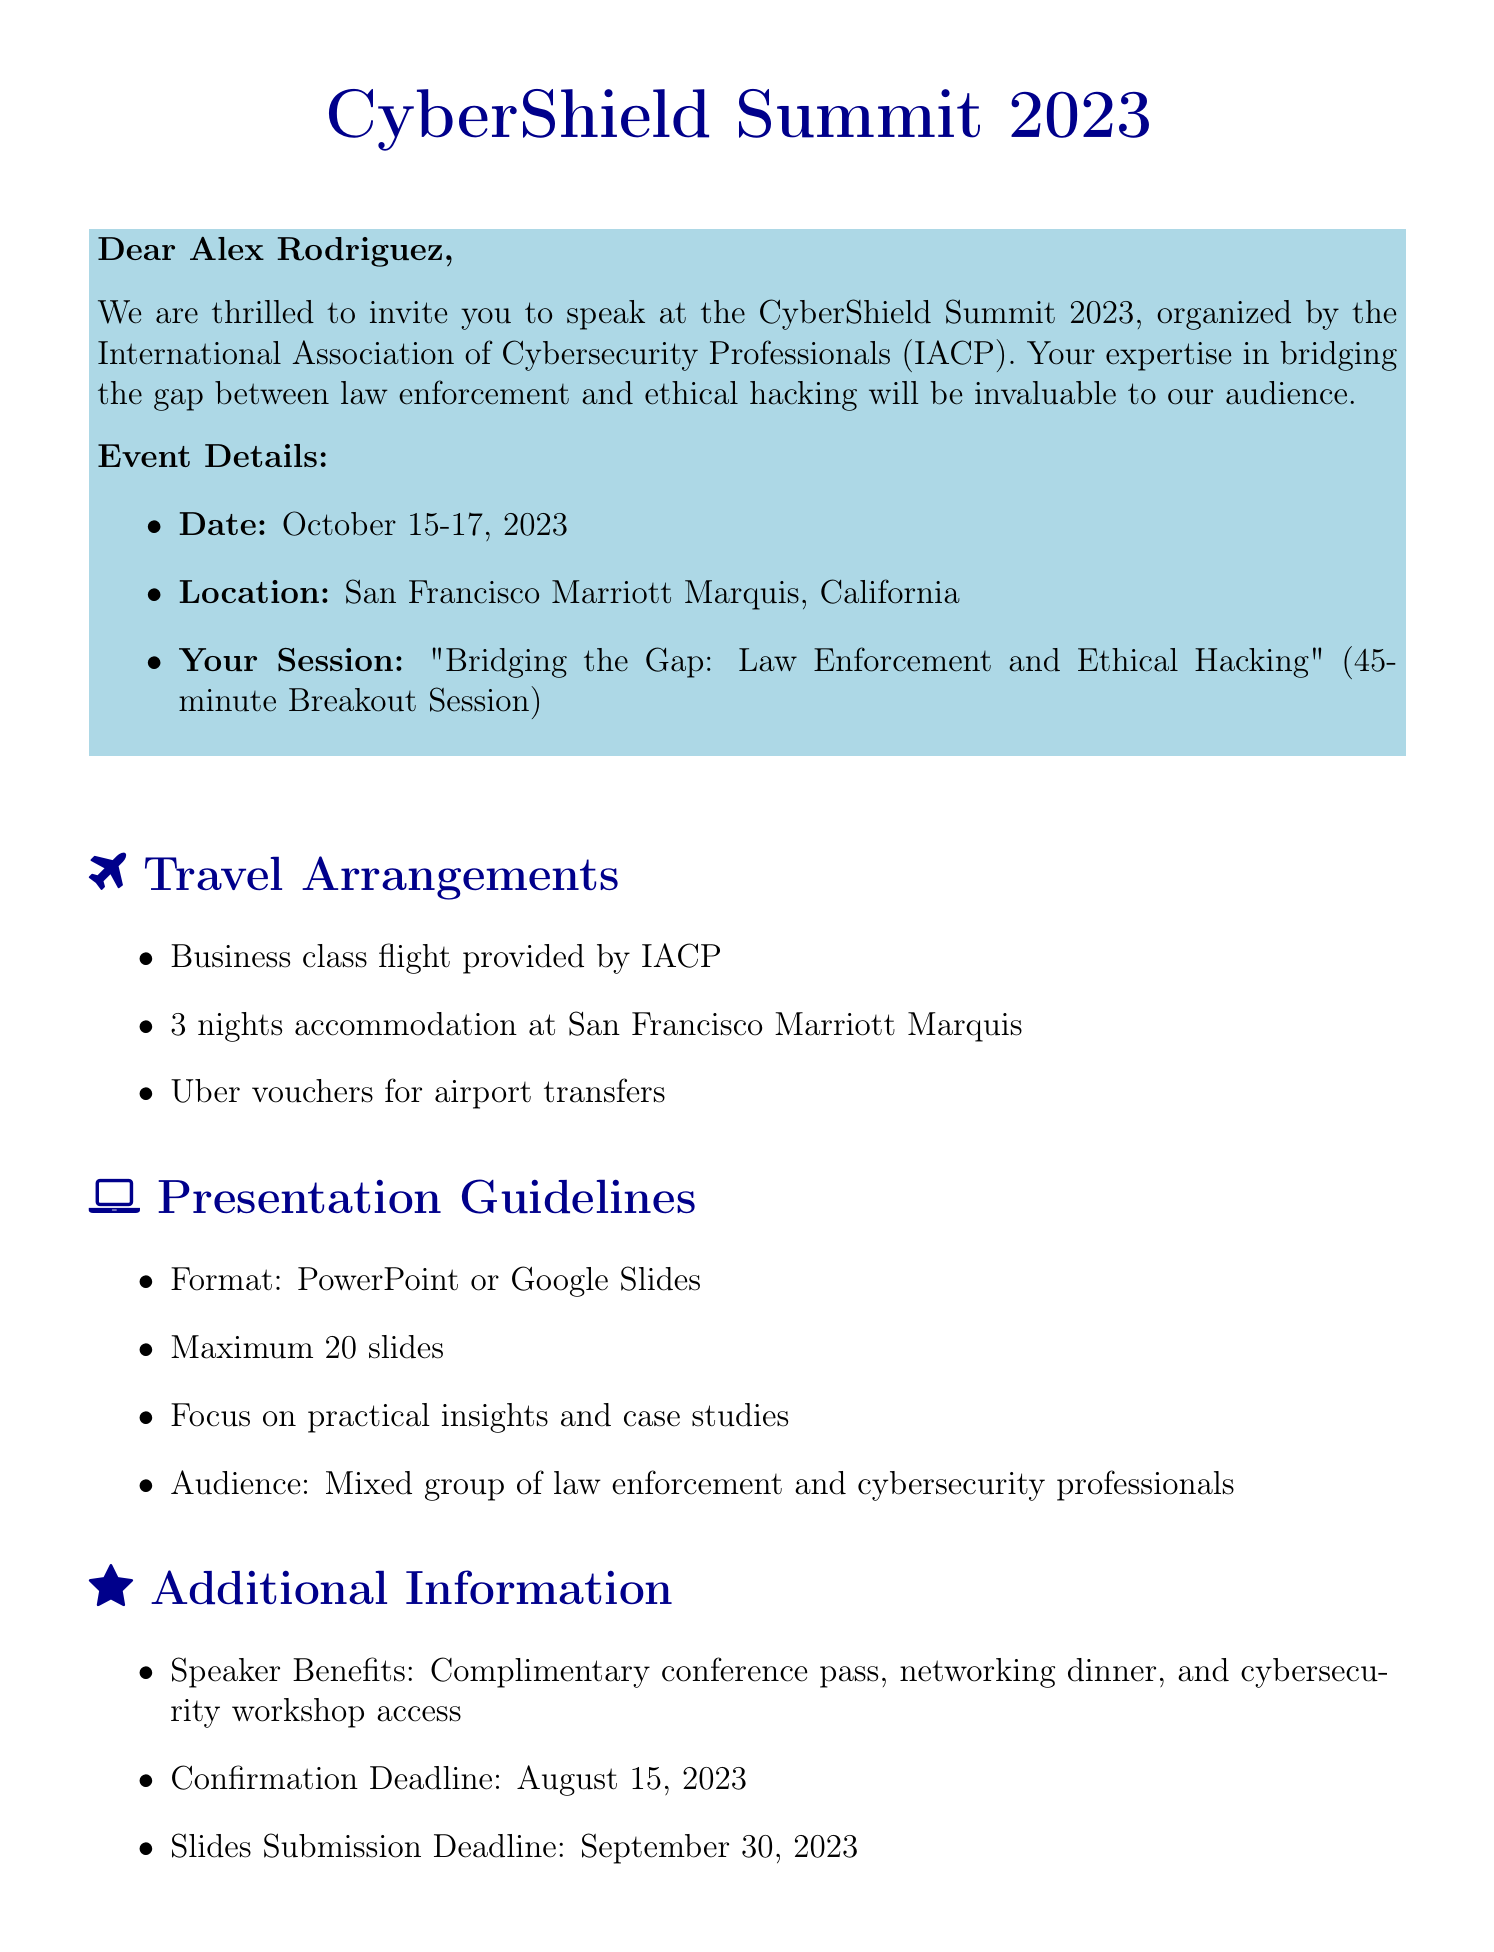What are the dates of the conference? The dates of the conference are specified in the document, which are October 15-17, 2023.
Answer: October 15-17, 2023 Who is the organizer of the event? According to the document, the organizer of the event is mentioned clearly, which is the International Association of Cybersecurity Professionals (IACP).
Answer: International Association of Cybersecurity Professionals (IACP) What is the title of Alex Rodriguez's presentation? The title of the presentation is provided in the invitation details section of the document.
Answer: Bridging the Gap: Law Enforcement and Ethical Hacking How long is the session duration? The session duration is stated in the invitation details and indicates how long Alex's presentation will be.
Answer: 45 minutes What type of transportation is provided for local transfers? The travel arrangements section specifies the kind of local transportation provided for the speaker.
Answer: Uber vouchers How many slides are allowed for the presentation? The presentation guidelines indicate a limit on the number of slides that can be included in the presentation.
Answer: Maximum 20 slides What is the confirmation deadline for the speaker? The additional information section mentions the deadline by which the speaker must confirm their participation.
Answer: August 15, 2023 What benefits does the speaker receive? The additional information outlines the perks the speaker will receive at the conference.
Answer: Complimentary conference pass, networking dinner, and cybersecurity workshop access 